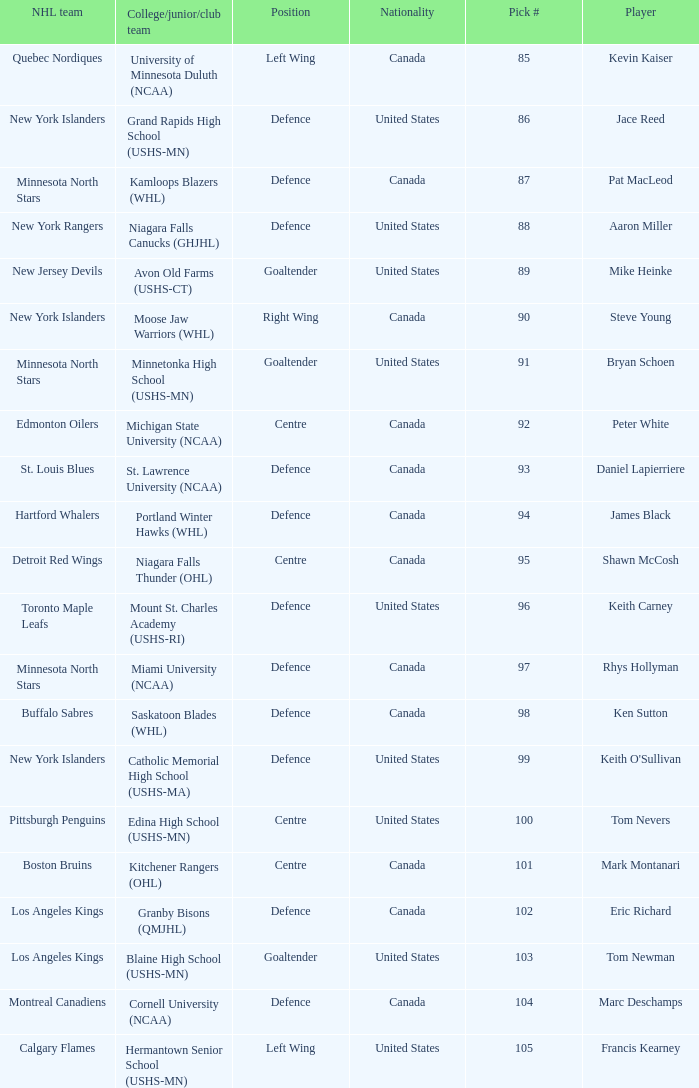What nationality is keith carney? United States. 